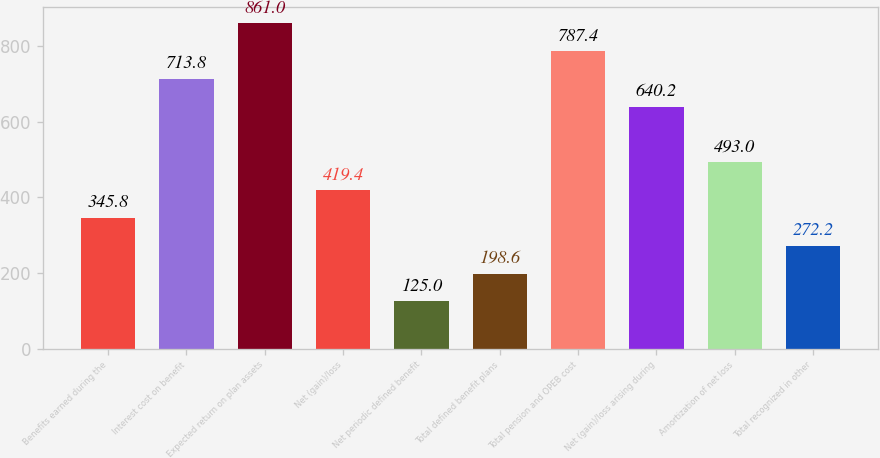<chart> <loc_0><loc_0><loc_500><loc_500><bar_chart><fcel>Benefits earned during the<fcel>Interest cost on benefit<fcel>Expected return on plan assets<fcel>Net (gain)/loss<fcel>Net periodic defined benefit<fcel>Total defined benefit plans<fcel>Total pension and OPEB cost<fcel>Net (gain)/loss arising during<fcel>Amortization of net loss<fcel>Total recognized in other<nl><fcel>345.8<fcel>713.8<fcel>861<fcel>419.4<fcel>125<fcel>198.6<fcel>787.4<fcel>640.2<fcel>493<fcel>272.2<nl></chart> 